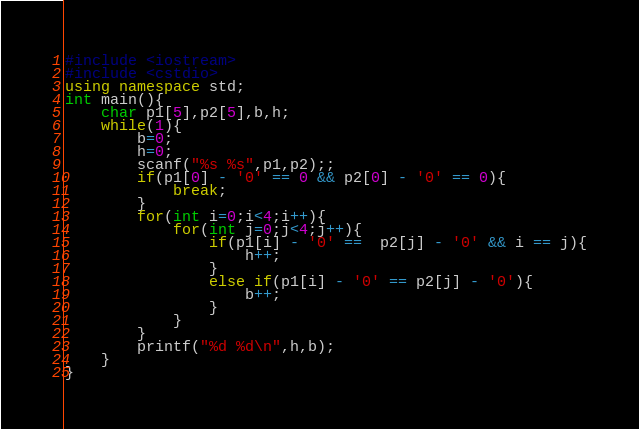Convert code to text. <code><loc_0><loc_0><loc_500><loc_500><_C++_>#include <iostream>
#include <cstdio>
using namespace std;
int main(){
    char p1[5],p2[5],b,h;
    while(1){
        b=0;
        h=0;
        scanf("%s %s",p1,p2);;
        if(p1[0] - '0' == 0 && p2[0] - '0' == 0){
            break;
        }
        for(int i=0;i<4;i++){
            for(int j=0;j<4;j++){
                if(p1[i] - '0' ==  p2[j] - '0' && i == j){
                    h++;
                }
                else if(p1[i] - '0' == p2[j] - '0'){
                    b++;
                }
            }
        }
        printf("%d %d\n",h,b);
    }
}</code> 